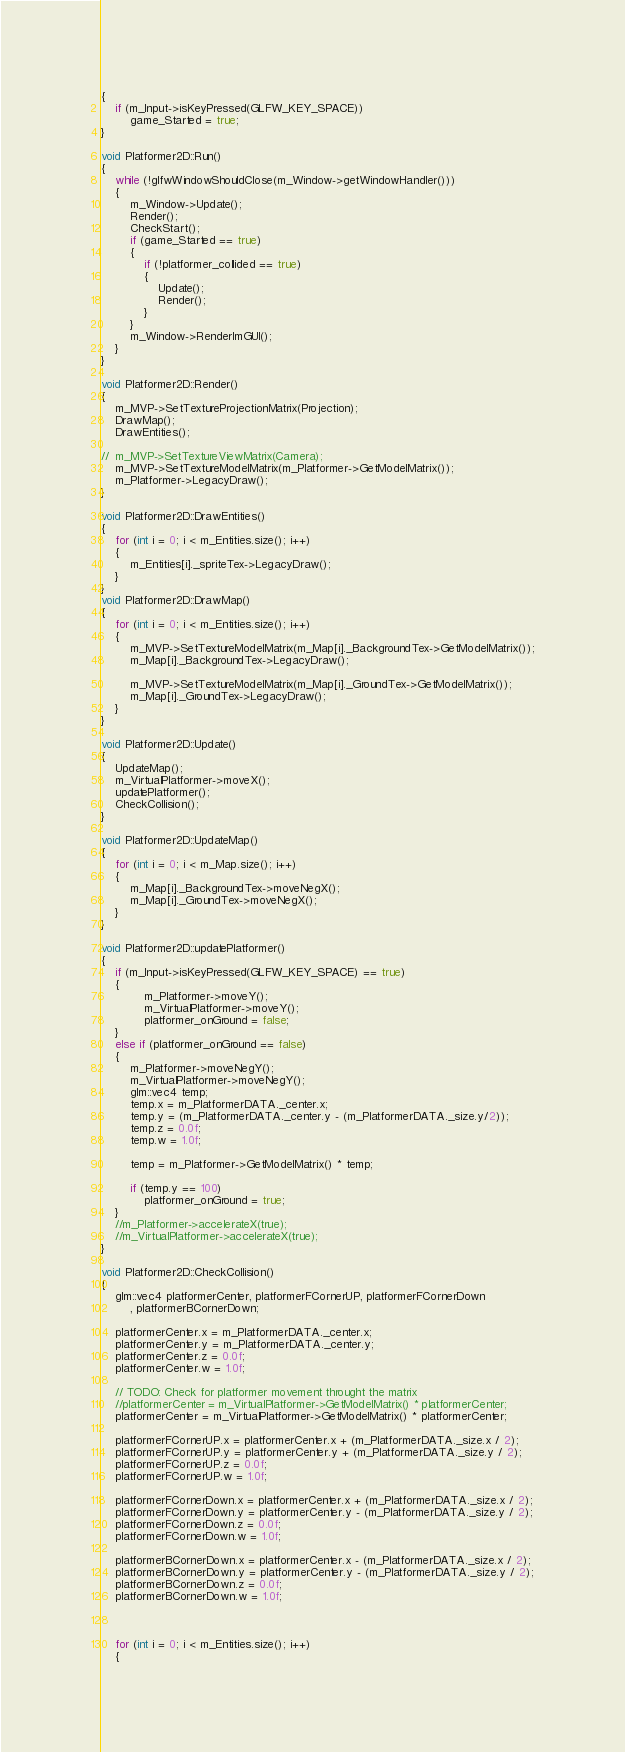Convert code to text. <code><loc_0><loc_0><loc_500><loc_500><_C++_>{
	if (m_Input->isKeyPressed(GLFW_KEY_SPACE))
		game_Started = true;
}

void Platformer2D::Run()
{
	while (!glfwWindowShouldClose(m_Window->getWindowHandler()))
	{
		m_Window->Update();
		Render();
		CheckStart();
		if (game_Started == true)
		{
			if (!platformer_collided == true)
			{
				Update();
				Render();
			}
		}
		m_Window->RenderImGUI();
	}
}

void Platformer2D::Render()
{
	m_MVP->SetTextureProjectionMatrix(Projection);
	DrawMap();
	DrawEntities();

//	m_MVP->SetTextureViewMatrix(Camera);
	m_MVP->SetTextureModelMatrix(m_Platformer->GetModelMatrix());
	m_Platformer->LegacyDraw();
}

void Platformer2D::DrawEntities()
{
	for (int i = 0; i < m_Entities.size(); i++)
	{
		m_Entities[i]._spriteTex->LegacyDraw();
	}
}
void Platformer2D::DrawMap()
{
	for (int i = 0; i < m_Entities.size(); i++)
	{
		m_MVP->SetTextureModelMatrix(m_Map[i]._BackgroundTex->GetModelMatrix());
		m_Map[i]._BackgroundTex->LegacyDraw();

		m_MVP->SetTextureModelMatrix(m_Map[i]._GroundTex->GetModelMatrix());
		m_Map[i]._GroundTex->LegacyDraw();
	}
}

void Platformer2D::Update()
{
	UpdateMap();
	m_VirtualPlatformer->moveX();
	updatePlatformer();
	CheckCollision();
}

void Platformer2D::UpdateMap()
{
	for (int i = 0; i < m_Map.size(); i++)
	{
		m_Map[i]._BackgroundTex->moveNegX();
		m_Map[i]._GroundTex->moveNegX();
	}
}

void Platformer2D::updatePlatformer()
{
	if (m_Input->isKeyPressed(GLFW_KEY_SPACE) == true)
	{
			m_Platformer->moveY();
			m_VirtualPlatformer->moveY();
			platformer_onGround = false;
	}
	else if (platformer_onGround == false)
	{
		m_Platformer->moveNegY();
		m_VirtualPlatformer->moveNegY();
		glm::vec4 temp;
		temp.x = m_PlatformerDATA._center.x;
		temp.y = (m_PlatformerDATA._center.y - (m_PlatformerDATA._size.y/2));
		temp.z = 0.0f;
		temp.w = 1.0f;

		temp = m_Platformer->GetModelMatrix() * temp;

		if (temp.y == 100)
			platformer_onGround = true;
	}
	//m_Platformer->accelerateX(true);
	//m_VirtualPlatformer->accelerateX(true);
}

void Platformer2D::CheckCollision()
{
	glm::vec4 platformerCenter, platformerFCornerUP, platformerFCornerDown
		, platformerBCornerDown;

	platformerCenter.x = m_PlatformerDATA._center.x;
	platformerCenter.y = m_PlatformerDATA._center.y;
	platformerCenter.z = 0.0f;
	platformerCenter.w = 1.0f;

	// TODO: Check for platformer movement throught the matrix
	//platformerCenter = m_VirtualPlatformer->GetModelMatrix() * platformerCenter;
	platformerCenter = m_VirtualPlatformer->GetModelMatrix() * platformerCenter;

	platformerFCornerUP.x = platformerCenter.x + (m_PlatformerDATA._size.x / 2);
	platformerFCornerUP.y = platformerCenter.y + (m_PlatformerDATA._size.y / 2);
	platformerFCornerUP.z = 0.0f;
	platformerFCornerUP.w = 1.0f;

	platformerFCornerDown.x = platformerCenter.x + (m_PlatformerDATA._size.x / 2);
	platformerFCornerDown.y = platformerCenter.y - (m_PlatformerDATA._size.y / 2);
	platformerFCornerDown.z = 0.0f;
	platformerFCornerDown.w = 1.0f;

	platformerBCornerDown.x = platformerCenter.x - (m_PlatformerDATA._size.x / 2);
	platformerBCornerDown.y = platformerCenter.y - (m_PlatformerDATA._size.y / 2);
	platformerBCornerDown.z = 0.0f;
	platformerBCornerDown.w = 1.0f;



	for (int i = 0; i < m_Entities.size(); i++)
	{</code> 